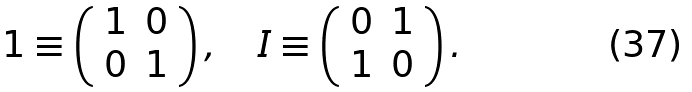<formula> <loc_0><loc_0><loc_500><loc_500>1 \equiv \left ( \begin{array} { c c } 1 & 0 \\ 0 & 1 \end{array} \right ) , \quad I \equiv \left ( \begin{array} { c c } 0 & 1 \\ 1 & 0 \end{array} \right ) .</formula> 